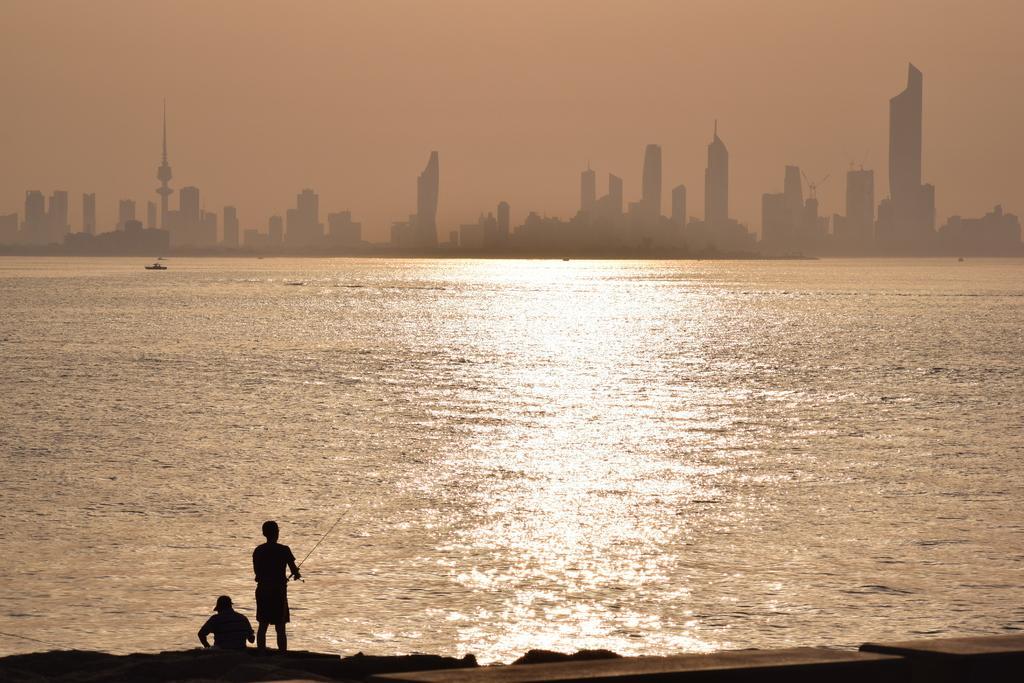Could you give a brief overview of what you see in this image? In this picture I can see there is a man standing and holding the fishing stick and there is another person sitting here. There is a ocean and there are buildings in the backdrop. 